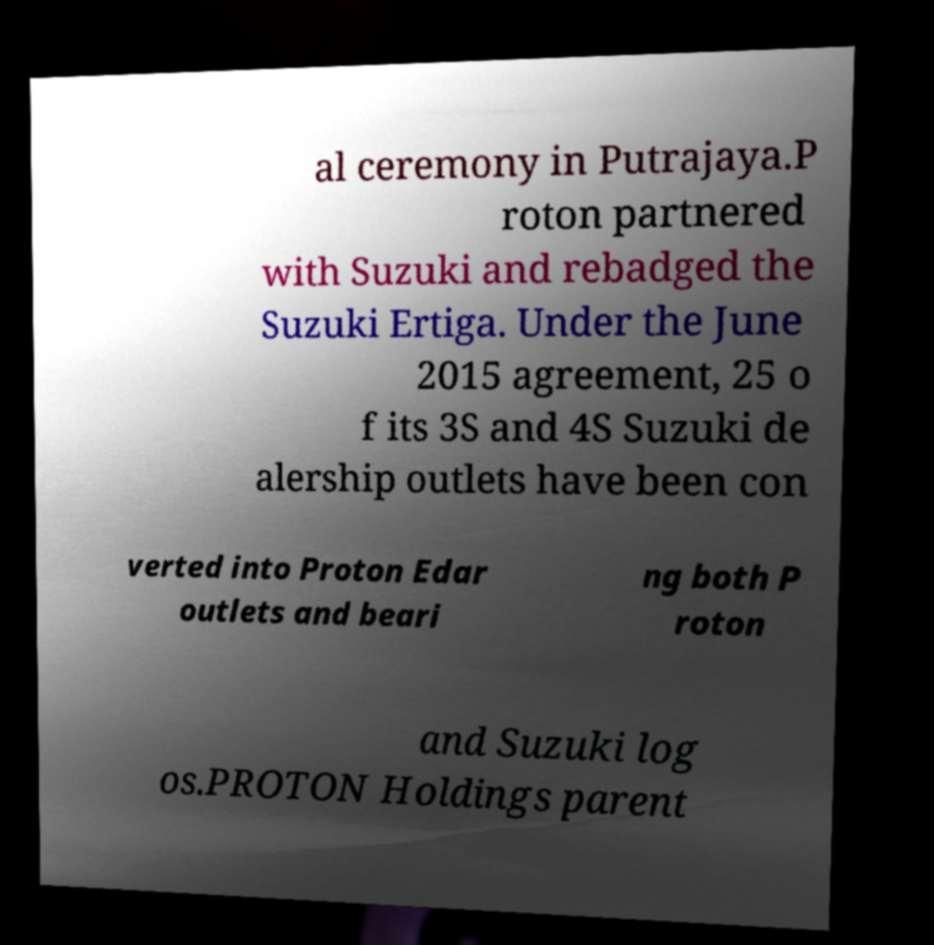Could you extract and type out the text from this image? al ceremony in Putrajaya.P roton partnered with Suzuki and rebadged the Suzuki Ertiga. Under the June 2015 agreement, 25 o f its 3S and 4S Suzuki de alership outlets have been con verted into Proton Edar outlets and beari ng both P roton and Suzuki log os.PROTON Holdings parent 